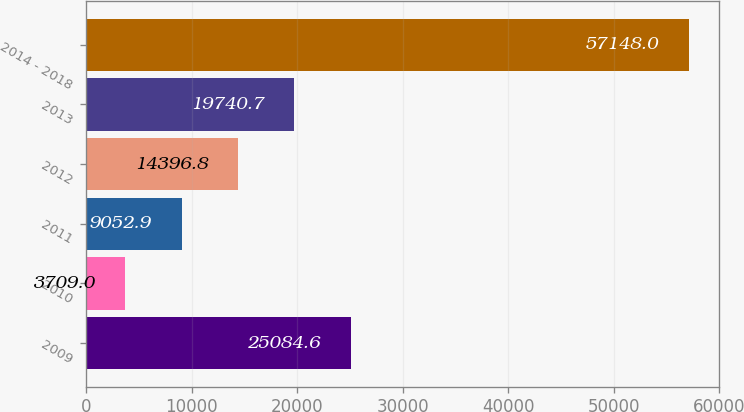Convert chart to OTSL. <chart><loc_0><loc_0><loc_500><loc_500><bar_chart><fcel>2009<fcel>2010<fcel>2011<fcel>2012<fcel>2013<fcel>2014 - 2018<nl><fcel>25084.6<fcel>3709<fcel>9052.9<fcel>14396.8<fcel>19740.7<fcel>57148<nl></chart> 